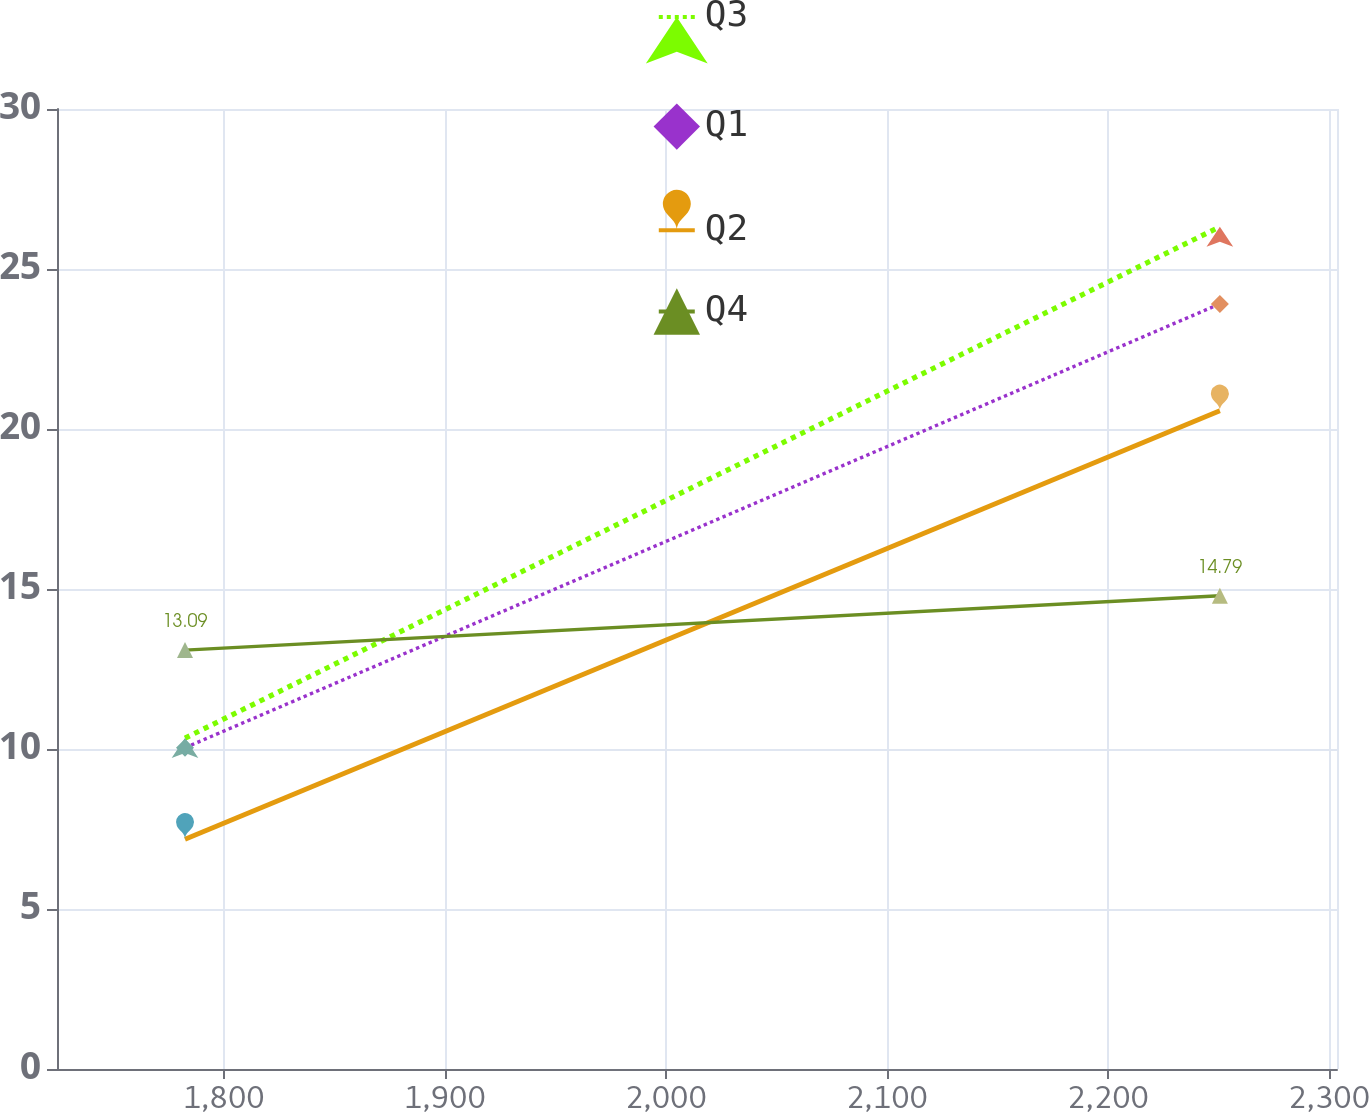<chart> <loc_0><loc_0><loc_500><loc_500><line_chart><ecel><fcel>Q3<fcel>Q1<fcel>Q2<fcel>Q4<nl><fcel>1782.49<fcel>10.34<fcel>10.04<fcel>7.18<fcel>13.09<nl><fcel>2250.6<fcel>26.32<fcel>23.91<fcel>20.57<fcel>14.79<nl><fcel>2361.49<fcel>24.8<fcel>26.92<fcel>23.18<fcel>30.11<nl></chart> 